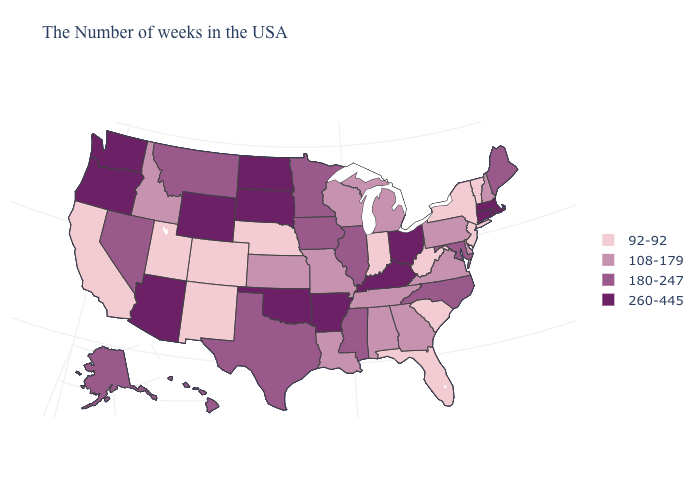Does the map have missing data?
Write a very short answer. No. Is the legend a continuous bar?
Keep it brief. No. How many symbols are there in the legend?
Be succinct. 4. Name the states that have a value in the range 180-247?
Concise answer only. Maine, Maryland, North Carolina, Illinois, Mississippi, Minnesota, Iowa, Texas, Montana, Nevada, Alaska, Hawaii. Name the states that have a value in the range 108-179?
Short answer required. New Hampshire, Delaware, Pennsylvania, Virginia, Georgia, Michigan, Alabama, Tennessee, Wisconsin, Louisiana, Missouri, Kansas, Idaho. Name the states that have a value in the range 108-179?
Short answer required. New Hampshire, Delaware, Pennsylvania, Virginia, Georgia, Michigan, Alabama, Tennessee, Wisconsin, Louisiana, Missouri, Kansas, Idaho. What is the value of Louisiana?
Concise answer only. 108-179. What is the lowest value in states that border Montana?
Short answer required. 108-179. What is the value of Connecticut?
Give a very brief answer. 260-445. Does Maryland have a lower value than Washington?
Give a very brief answer. Yes. What is the highest value in the MidWest ?
Give a very brief answer. 260-445. What is the value of Illinois?
Be succinct. 180-247. What is the highest value in the USA?
Concise answer only. 260-445. Name the states that have a value in the range 180-247?
Write a very short answer. Maine, Maryland, North Carolina, Illinois, Mississippi, Minnesota, Iowa, Texas, Montana, Nevada, Alaska, Hawaii. What is the value of Colorado?
Be succinct. 92-92. 